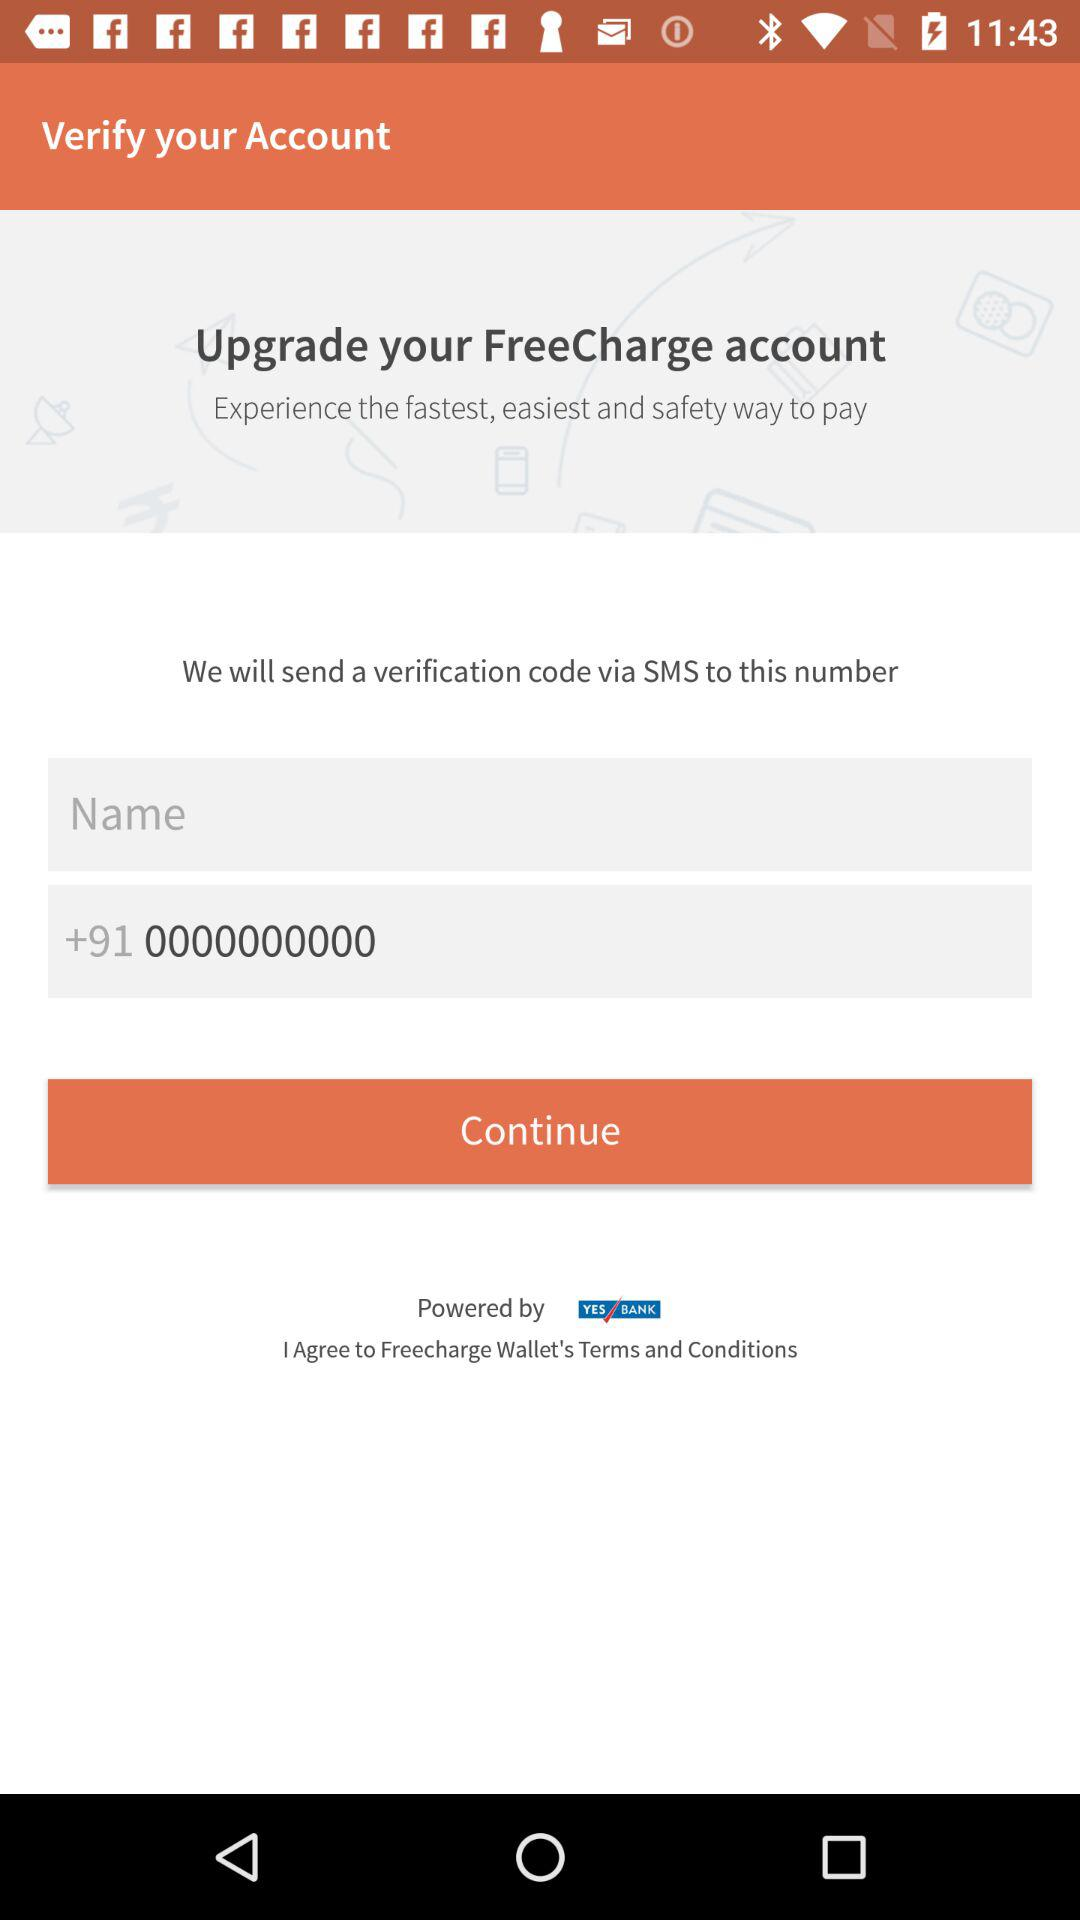What is the entered number? The entered number is 0000000000. 